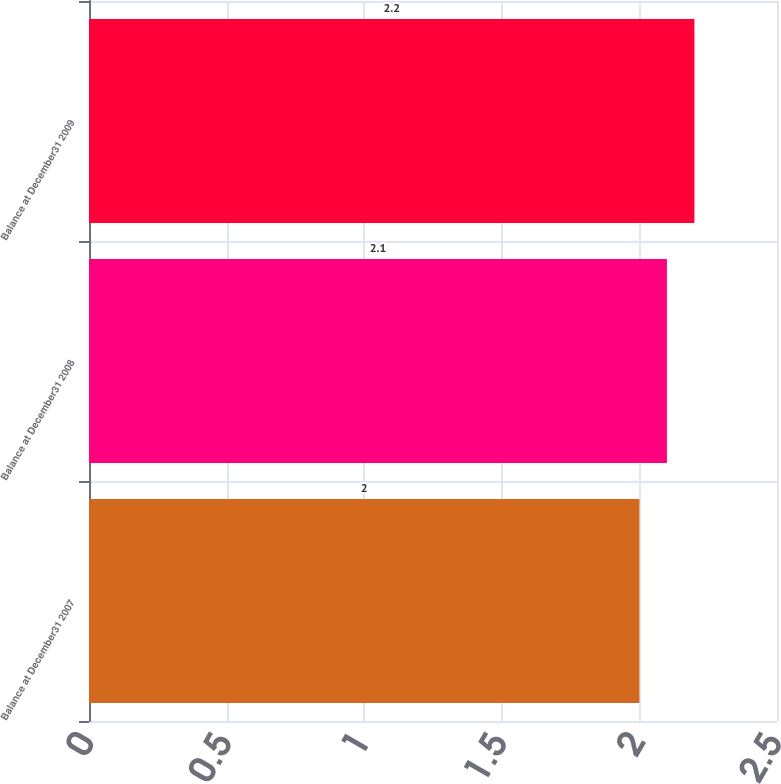Convert chart to OTSL. <chart><loc_0><loc_0><loc_500><loc_500><bar_chart><fcel>Balance at December31 2007<fcel>Balance at December31 2008<fcel>Balance at December31 2009<nl><fcel>2<fcel>2.1<fcel>2.2<nl></chart> 